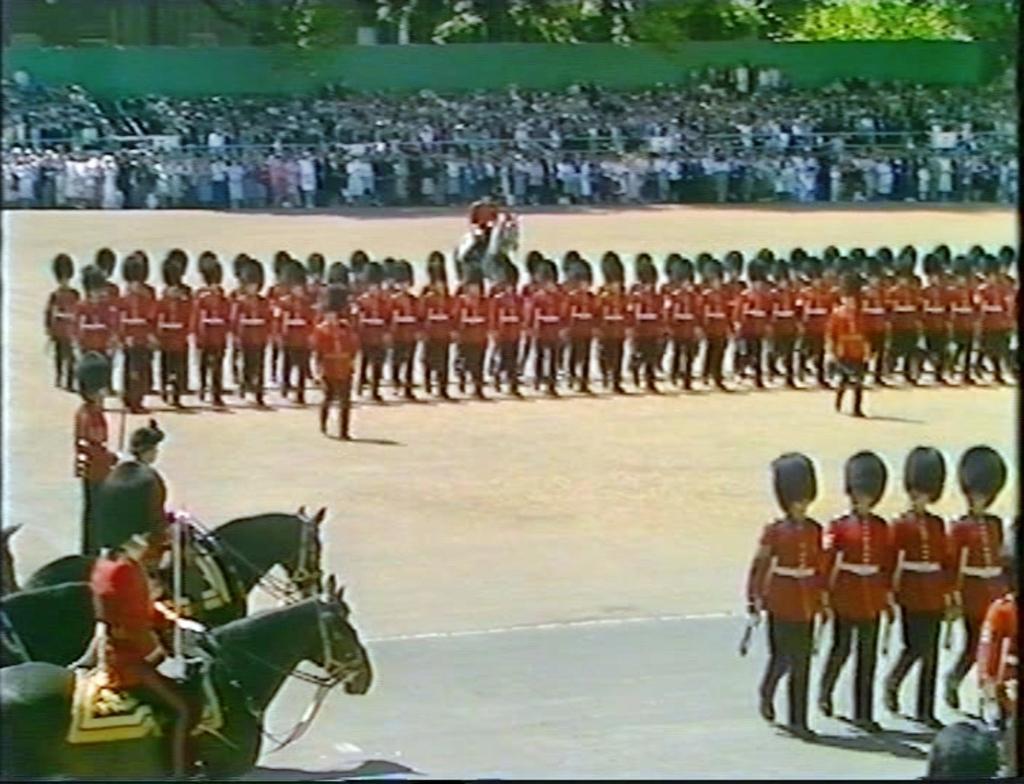In one or two sentences, can you explain what this image depicts? Here we can see people. Far we can see crows and trees. These three people are sitting on horses. 